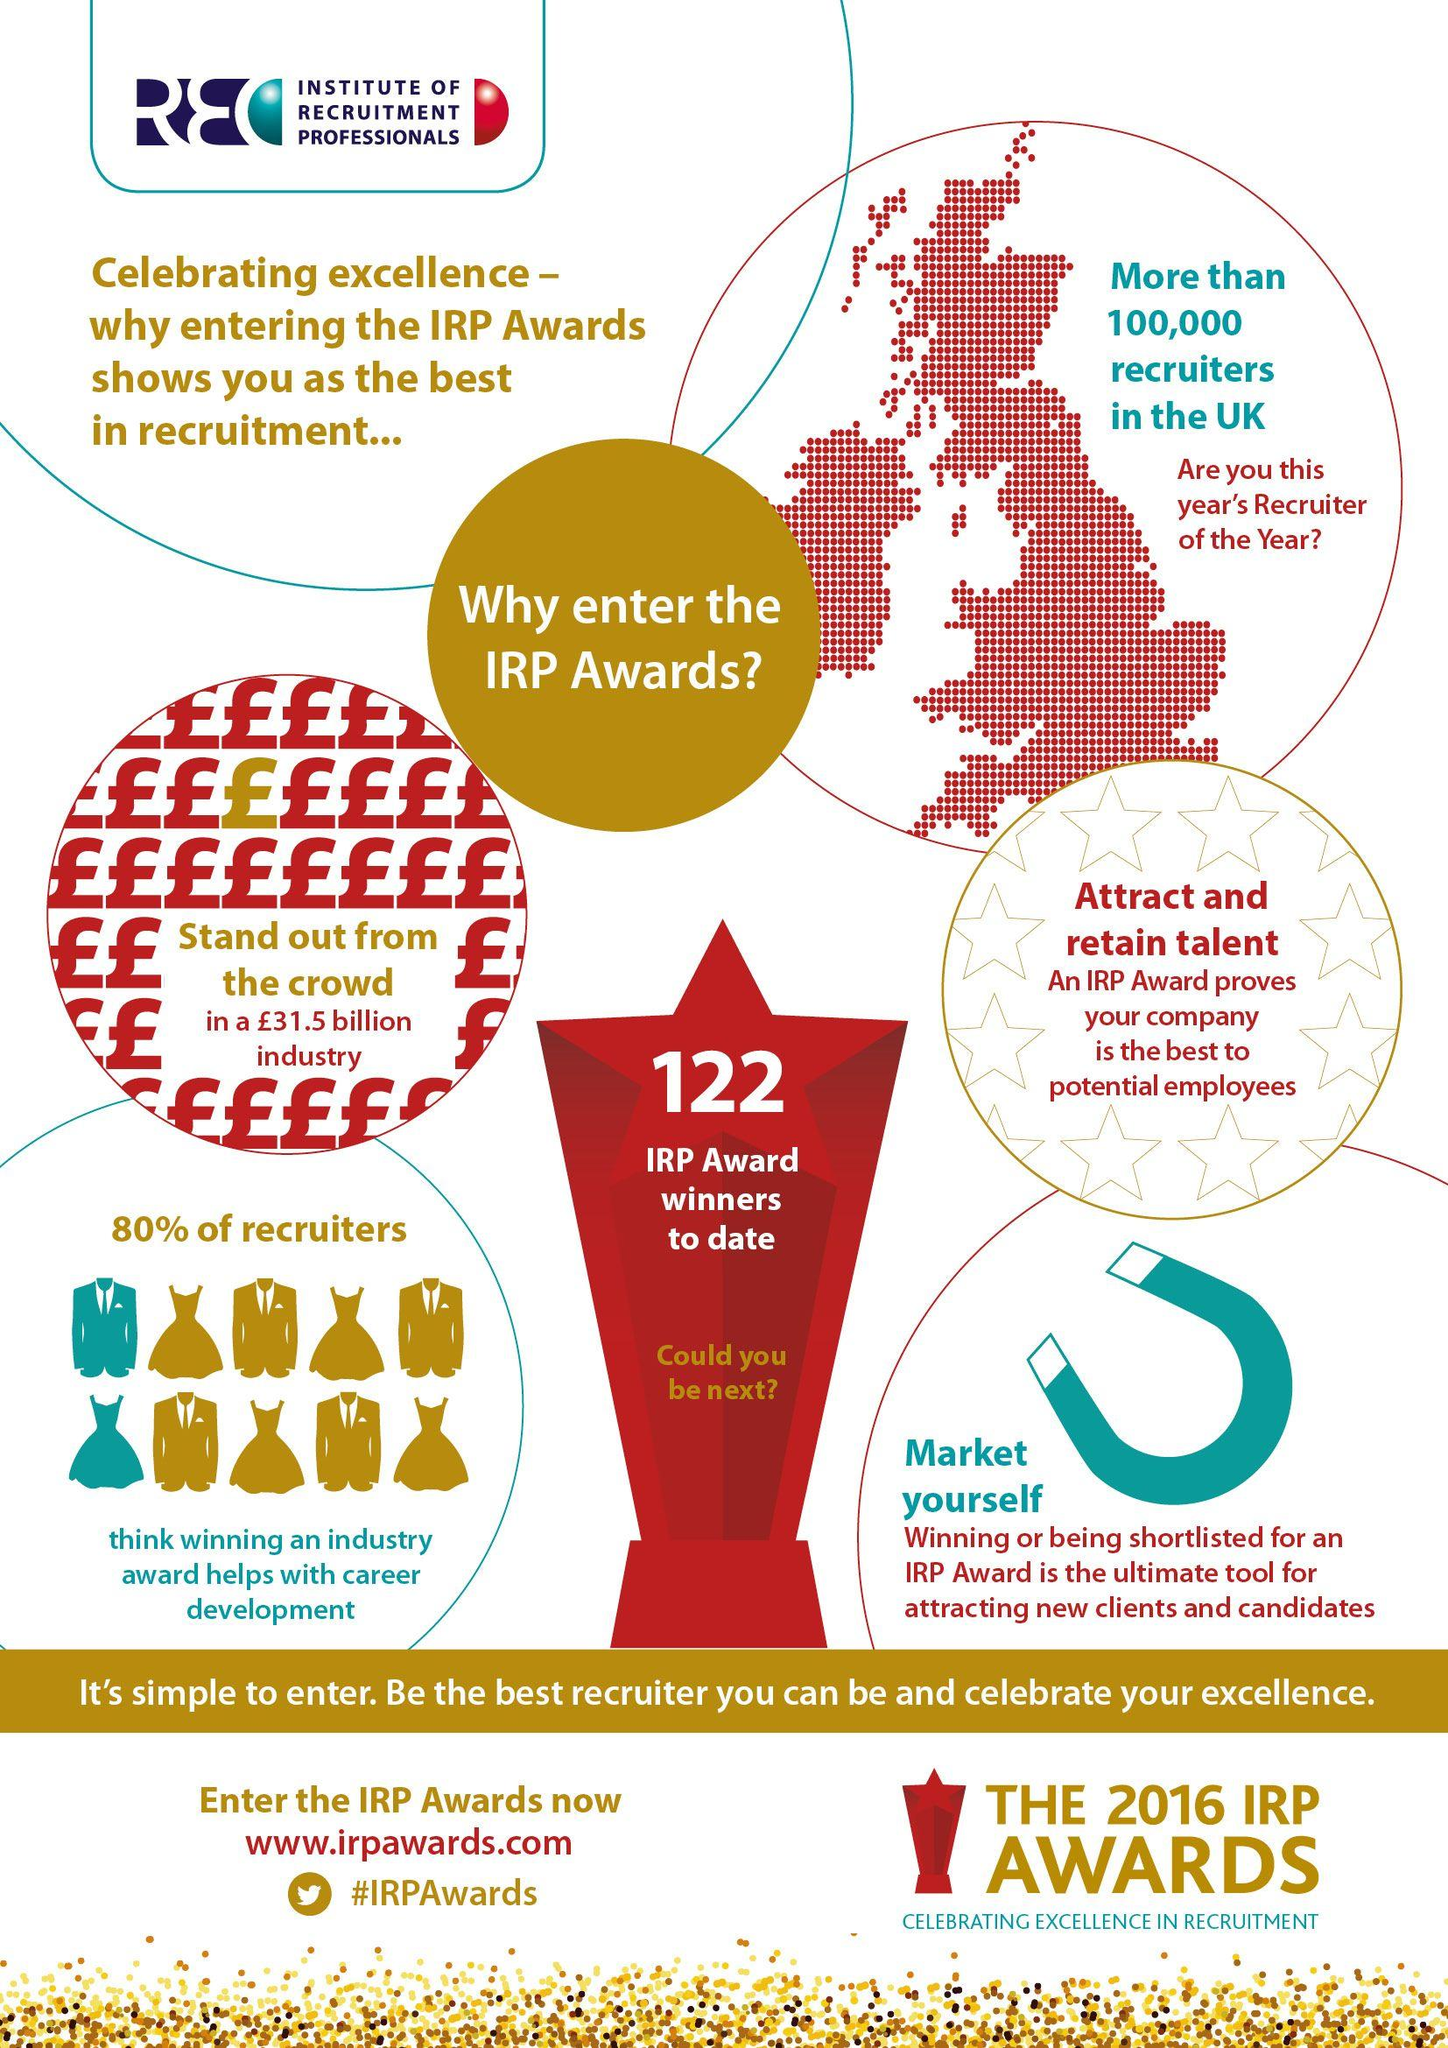Outline some significant characteristics in this image. In a survey of recruiters, it was found that 20% do not believe that winning an industry award helps with career development. The number written on the trophy is 122. 